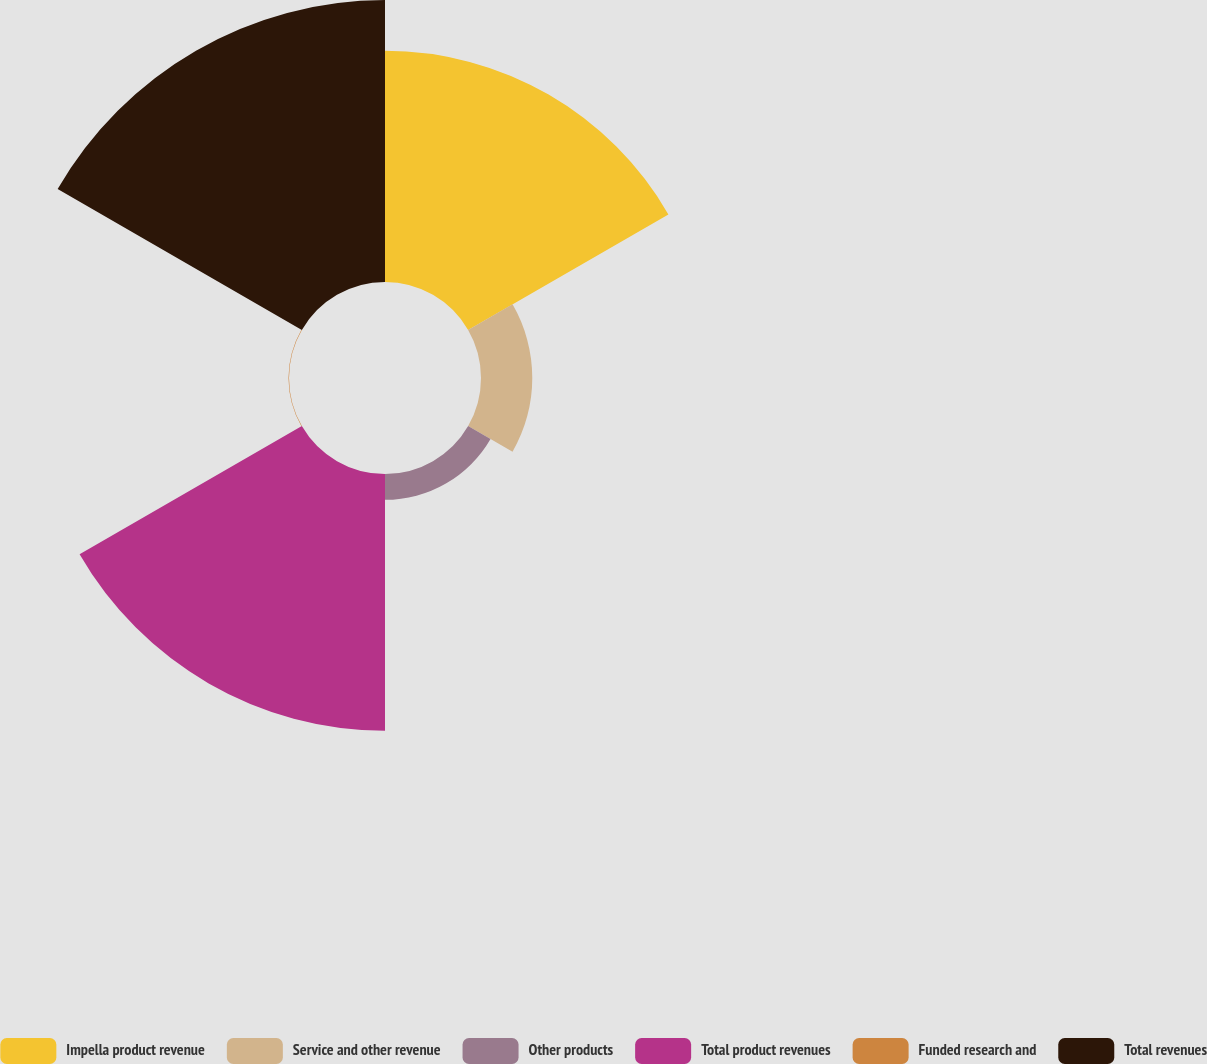Convert chart to OTSL. <chart><loc_0><loc_0><loc_500><loc_500><pie_chart><fcel>Impella product revenue<fcel>Service and other revenue<fcel>Other products<fcel>Total product revenues<fcel>Funded research and<fcel>Total revenues<nl><fcel>27.28%<fcel>6.05%<fcel>3.05%<fcel>30.28%<fcel>0.06%<fcel>33.27%<nl></chart> 